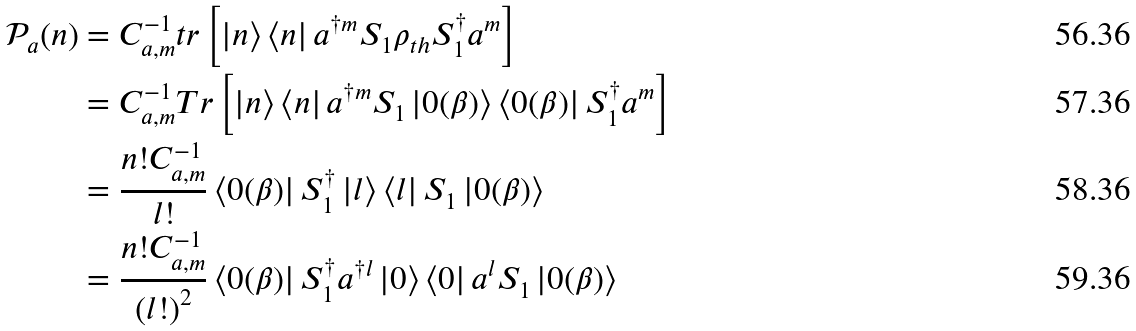<formula> <loc_0><loc_0><loc_500><loc_500>\mathcal { P } _ { a } ( n ) & = C _ { a , m } ^ { - 1 } t r \left [ \left | n \right \rangle \left \langle n \right | a ^ { \dag m } S _ { 1 } \rho _ { t h } S _ { 1 } ^ { \dagger } a ^ { m } \right ] \\ & = C _ { a , m } ^ { - 1 } T r \left [ \left | n \right \rangle \left \langle n \right | a ^ { \dag m } S _ { 1 } \left | 0 ( \beta ) \right \rangle \left \langle 0 ( \beta ) \right | S _ { 1 } ^ { \dagger } a ^ { m } \right ] \\ & = \frac { n ! C _ { a , m } ^ { - 1 } } { l ! } \left \langle 0 ( \beta ) \right | S _ { 1 } ^ { \dagger } \left | l \right \rangle \left \langle l \right | S _ { 1 } \left | 0 ( \beta ) \right \rangle \\ & = \frac { n ! C _ { a , m } ^ { - 1 } } { \left ( l ! \right ) ^ { 2 } } \left \langle 0 ( \beta ) \right | S _ { 1 } ^ { \dagger } a ^ { \dagger l } \left | 0 \right \rangle \left \langle 0 \right | a ^ { l } S _ { 1 } \left | 0 ( \beta ) \right \rangle</formula> 